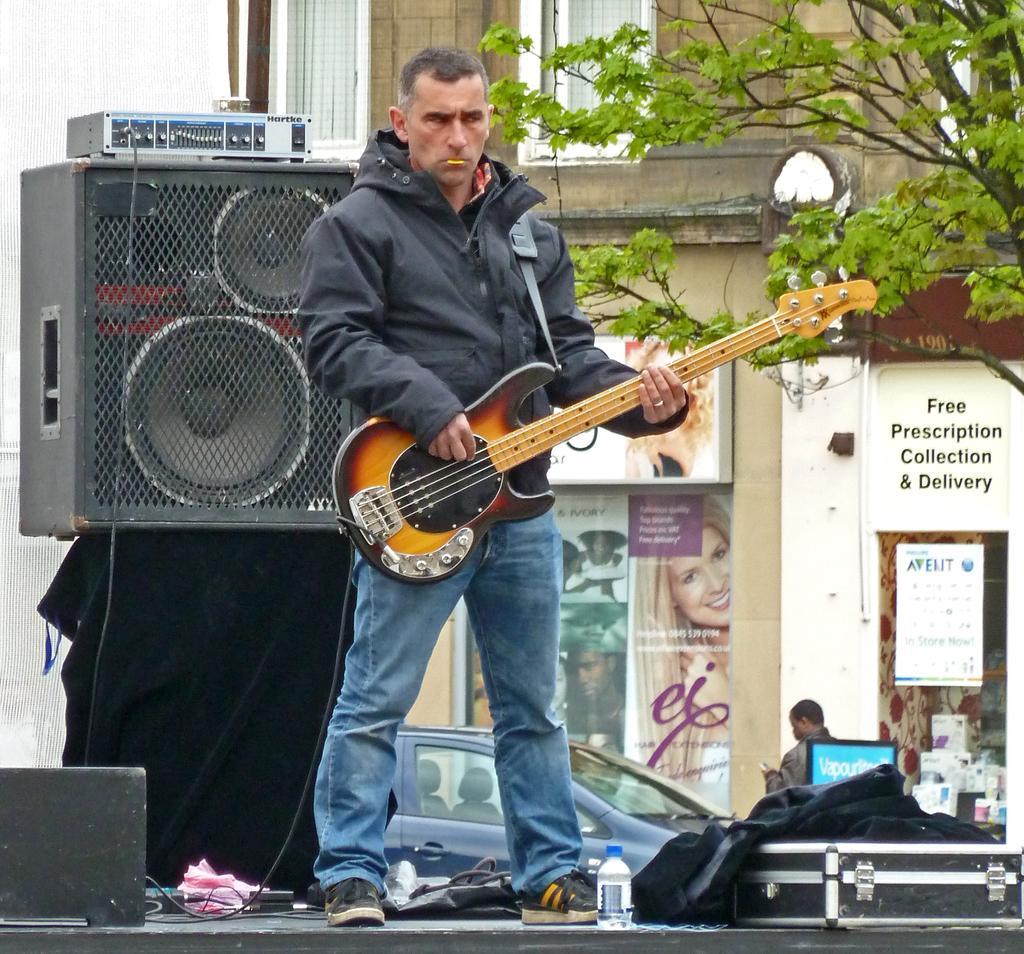What is the man in the image doing? The man is playing a guitar in the image. What can be seen near the man? There are speakers visible in the image. What is visible in the background of the image? There is a building, a tree, posters, and cars in the background of the image. What type of paste is the man using to play the guitar in the image? There is no paste mentioned or visible in the image; the man is playing the guitar with his hands. 